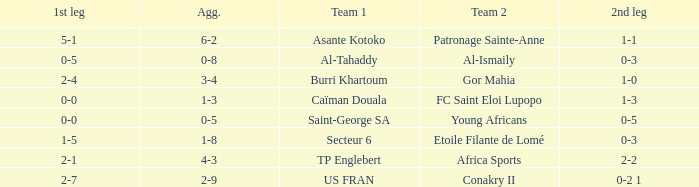Which team lost 0-3 and 0-5? Al-Tahaddy. 